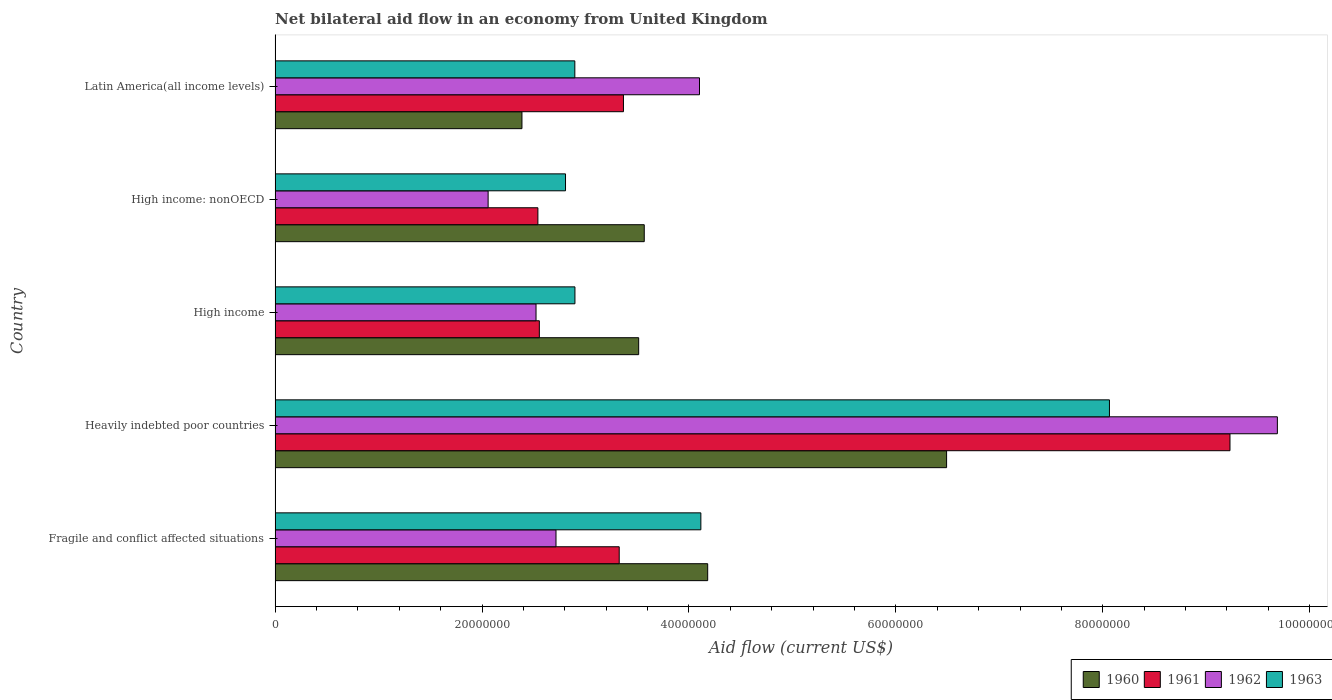How many different coloured bars are there?
Make the answer very short. 4. Are the number of bars on each tick of the Y-axis equal?
Your response must be concise. Yes. How many bars are there on the 1st tick from the top?
Ensure brevity in your answer.  4. What is the label of the 1st group of bars from the top?
Provide a short and direct response. Latin America(all income levels). In how many cases, is the number of bars for a given country not equal to the number of legend labels?
Give a very brief answer. 0. What is the net bilateral aid flow in 1960 in Fragile and conflict affected situations?
Ensure brevity in your answer.  4.18e+07. Across all countries, what is the maximum net bilateral aid flow in 1960?
Provide a succinct answer. 6.49e+07. Across all countries, what is the minimum net bilateral aid flow in 1961?
Ensure brevity in your answer.  2.54e+07. In which country was the net bilateral aid flow in 1962 maximum?
Your answer should be compact. Heavily indebted poor countries. In which country was the net bilateral aid flow in 1960 minimum?
Your answer should be compact. Latin America(all income levels). What is the total net bilateral aid flow in 1963 in the graph?
Your answer should be very brief. 2.08e+08. What is the difference between the net bilateral aid flow in 1961 in Heavily indebted poor countries and that in Latin America(all income levels)?
Offer a terse response. 5.86e+07. What is the difference between the net bilateral aid flow in 1961 in Latin America(all income levels) and the net bilateral aid flow in 1960 in Heavily indebted poor countries?
Keep it short and to the point. -3.12e+07. What is the average net bilateral aid flow in 1960 per country?
Ensure brevity in your answer.  4.03e+07. What is the difference between the net bilateral aid flow in 1963 and net bilateral aid flow in 1960 in Fragile and conflict affected situations?
Your response must be concise. -6.60e+05. In how many countries, is the net bilateral aid flow in 1960 greater than 68000000 US$?
Your answer should be compact. 0. What is the ratio of the net bilateral aid flow in 1960 in High income to that in Latin America(all income levels)?
Make the answer very short. 1.47. Is the net bilateral aid flow in 1963 in Fragile and conflict affected situations less than that in Heavily indebted poor countries?
Provide a succinct answer. Yes. Is the difference between the net bilateral aid flow in 1963 in High income and Latin America(all income levels) greater than the difference between the net bilateral aid flow in 1960 in High income and Latin America(all income levels)?
Provide a short and direct response. No. What is the difference between the highest and the second highest net bilateral aid flow in 1961?
Your answer should be very brief. 5.86e+07. What is the difference between the highest and the lowest net bilateral aid flow in 1961?
Provide a short and direct response. 6.69e+07. In how many countries, is the net bilateral aid flow in 1961 greater than the average net bilateral aid flow in 1961 taken over all countries?
Provide a succinct answer. 1. What is the difference between two consecutive major ticks on the X-axis?
Your response must be concise. 2.00e+07. Does the graph contain grids?
Your response must be concise. No. How are the legend labels stacked?
Your response must be concise. Horizontal. What is the title of the graph?
Offer a terse response. Net bilateral aid flow in an economy from United Kingdom. Does "1972" appear as one of the legend labels in the graph?
Give a very brief answer. No. What is the label or title of the X-axis?
Give a very brief answer. Aid flow (current US$). What is the Aid flow (current US$) of 1960 in Fragile and conflict affected situations?
Offer a very short reply. 4.18e+07. What is the Aid flow (current US$) in 1961 in Fragile and conflict affected situations?
Keep it short and to the point. 3.33e+07. What is the Aid flow (current US$) in 1962 in Fragile and conflict affected situations?
Offer a terse response. 2.72e+07. What is the Aid flow (current US$) in 1963 in Fragile and conflict affected situations?
Your response must be concise. 4.12e+07. What is the Aid flow (current US$) in 1960 in Heavily indebted poor countries?
Keep it short and to the point. 6.49e+07. What is the Aid flow (current US$) of 1961 in Heavily indebted poor countries?
Give a very brief answer. 9.23e+07. What is the Aid flow (current US$) in 1962 in Heavily indebted poor countries?
Keep it short and to the point. 9.69e+07. What is the Aid flow (current US$) of 1963 in Heavily indebted poor countries?
Keep it short and to the point. 8.06e+07. What is the Aid flow (current US$) of 1960 in High income?
Give a very brief answer. 3.51e+07. What is the Aid flow (current US$) in 1961 in High income?
Ensure brevity in your answer.  2.55e+07. What is the Aid flow (current US$) in 1962 in High income?
Keep it short and to the point. 2.52e+07. What is the Aid flow (current US$) in 1963 in High income?
Give a very brief answer. 2.90e+07. What is the Aid flow (current US$) of 1960 in High income: nonOECD?
Keep it short and to the point. 3.57e+07. What is the Aid flow (current US$) of 1961 in High income: nonOECD?
Provide a succinct answer. 2.54e+07. What is the Aid flow (current US$) in 1962 in High income: nonOECD?
Your answer should be very brief. 2.06e+07. What is the Aid flow (current US$) of 1963 in High income: nonOECD?
Your answer should be very brief. 2.81e+07. What is the Aid flow (current US$) in 1960 in Latin America(all income levels)?
Your answer should be very brief. 2.39e+07. What is the Aid flow (current US$) of 1961 in Latin America(all income levels)?
Provide a succinct answer. 3.37e+07. What is the Aid flow (current US$) in 1962 in Latin America(all income levels)?
Your response must be concise. 4.10e+07. What is the Aid flow (current US$) of 1963 in Latin America(all income levels)?
Provide a succinct answer. 2.90e+07. Across all countries, what is the maximum Aid flow (current US$) of 1960?
Provide a short and direct response. 6.49e+07. Across all countries, what is the maximum Aid flow (current US$) in 1961?
Your response must be concise. 9.23e+07. Across all countries, what is the maximum Aid flow (current US$) in 1962?
Provide a succinct answer. 9.69e+07. Across all countries, what is the maximum Aid flow (current US$) of 1963?
Offer a terse response. 8.06e+07. Across all countries, what is the minimum Aid flow (current US$) of 1960?
Ensure brevity in your answer.  2.39e+07. Across all countries, what is the minimum Aid flow (current US$) of 1961?
Your response must be concise. 2.54e+07. Across all countries, what is the minimum Aid flow (current US$) in 1962?
Offer a very short reply. 2.06e+07. Across all countries, what is the minimum Aid flow (current US$) in 1963?
Give a very brief answer. 2.81e+07. What is the total Aid flow (current US$) of 1960 in the graph?
Give a very brief answer. 2.01e+08. What is the total Aid flow (current US$) of 1961 in the graph?
Your answer should be very brief. 2.10e+08. What is the total Aid flow (current US$) of 1962 in the graph?
Provide a succinct answer. 2.11e+08. What is the total Aid flow (current US$) of 1963 in the graph?
Your response must be concise. 2.08e+08. What is the difference between the Aid flow (current US$) in 1960 in Fragile and conflict affected situations and that in Heavily indebted poor countries?
Provide a succinct answer. -2.31e+07. What is the difference between the Aid flow (current US$) in 1961 in Fragile and conflict affected situations and that in Heavily indebted poor countries?
Offer a terse response. -5.90e+07. What is the difference between the Aid flow (current US$) in 1962 in Fragile and conflict affected situations and that in Heavily indebted poor countries?
Your response must be concise. -6.97e+07. What is the difference between the Aid flow (current US$) of 1963 in Fragile and conflict affected situations and that in Heavily indebted poor countries?
Keep it short and to the point. -3.95e+07. What is the difference between the Aid flow (current US$) in 1960 in Fragile and conflict affected situations and that in High income?
Offer a very short reply. 6.67e+06. What is the difference between the Aid flow (current US$) in 1961 in Fragile and conflict affected situations and that in High income?
Provide a short and direct response. 7.72e+06. What is the difference between the Aid flow (current US$) in 1962 in Fragile and conflict affected situations and that in High income?
Give a very brief answer. 1.93e+06. What is the difference between the Aid flow (current US$) in 1963 in Fragile and conflict affected situations and that in High income?
Provide a succinct answer. 1.22e+07. What is the difference between the Aid flow (current US$) of 1960 in Fragile and conflict affected situations and that in High income: nonOECD?
Your answer should be very brief. 6.13e+06. What is the difference between the Aid flow (current US$) in 1961 in Fragile and conflict affected situations and that in High income: nonOECD?
Offer a very short reply. 7.86e+06. What is the difference between the Aid flow (current US$) of 1962 in Fragile and conflict affected situations and that in High income: nonOECD?
Give a very brief answer. 6.56e+06. What is the difference between the Aid flow (current US$) of 1963 in Fragile and conflict affected situations and that in High income: nonOECD?
Give a very brief answer. 1.31e+07. What is the difference between the Aid flow (current US$) of 1960 in Fragile and conflict affected situations and that in Latin America(all income levels)?
Keep it short and to the point. 1.80e+07. What is the difference between the Aid flow (current US$) in 1961 in Fragile and conflict affected situations and that in Latin America(all income levels)?
Your response must be concise. -4.10e+05. What is the difference between the Aid flow (current US$) of 1962 in Fragile and conflict affected situations and that in Latin America(all income levels)?
Keep it short and to the point. -1.39e+07. What is the difference between the Aid flow (current US$) in 1963 in Fragile and conflict affected situations and that in Latin America(all income levels)?
Offer a very short reply. 1.22e+07. What is the difference between the Aid flow (current US$) of 1960 in Heavily indebted poor countries and that in High income?
Give a very brief answer. 2.98e+07. What is the difference between the Aid flow (current US$) in 1961 in Heavily indebted poor countries and that in High income?
Provide a succinct answer. 6.68e+07. What is the difference between the Aid flow (current US$) of 1962 in Heavily indebted poor countries and that in High income?
Offer a terse response. 7.16e+07. What is the difference between the Aid flow (current US$) in 1963 in Heavily indebted poor countries and that in High income?
Give a very brief answer. 5.17e+07. What is the difference between the Aid flow (current US$) in 1960 in Heavily indebted poor countries and that in High income: nonOECD?
Offer a very short reply. 2.92e+07. What is the difference between the Aid flow (current US$) in 1961 in Heavily indebted poor countries and that in High income: nonOECD?
Your response must be concise. 6.69e+07. What is the difference between the Aid flow (current US$) in 1962 in Heavily indebted poor countries and that in High income: nonOECD?
Provide a short and direct response. 7.63e+07. What is the difference between the Aid flow (current US$) in 1963 in Heavily indebted poor countries and that in High income: nonOECD?
Your answer should be compact. 5.26e+07. What is the difference between the Aid flow (current US$) of 1960 in Heavily indebted poor countries and that in Latin America(all income levels)?
Ensure brevity in your answer.  4.10e+07. What is the difference between the Aid flow (current US$) of 1961 in Heavily indebted poor countries and that in Latin America(all income levels)?
Ensure brevity in your answer.  5.86e+07. What is the difference between the Aid flow (current US$) in 1962 in Heavily indebted poor countries and that in Latin America(all income levels)?
Offer a terse response. 5.58e+07. What is the difference between the Aid flow (current US$) of 1963 in Heavily indebted poor countries and that in Latin America(all income levels)?
Ensure brevity in your answer.  5.17e+07. What is the difference between the Aid flow (current US$) of 1960 in High income and that in High income: nonOECD?
Provide a succinct answer. -5.40e+05. What is the difference between the Aid flow (current US$) in 1962 in High income and that in High income: nonOECD?
Make the answer very short. 4.63e+06. What is the difference between the Aid flow (current US$) in 1963 in High income and that in High income: nonOECD?
Keep it short and to the point. 9.10e+05. What is the difference between the Aid flow (current US$) of 1960 in High income and that in Latin America(all income levels)?
Your answer should be very brief. 1.13e+07. What is the difference between the Aid flow (current US$) of 1961 in High income and that in Latin America(all income levels)?
Make the answer very short. -8.13e+06. What is the difference between the Aid flow (current US$) of 1962 in High income and that in Latin America(all income levels)?
Keep it short and to the point. -1.58e+07. What is the difference between the Aid flow (current US$) in 1963 in High income and that in Latin America(all income levels)?
Provide a short and direct response. 10000. What is the difference between the Aid flow (current US$) in 1960 in High income: nonOECD and that in Latin America(all income levels)?
Provide a short and direct response. 1.18e+07. What is the difference between the Aid flow (current US$) in 1961 in High income: nonOECD and that in Latin America(all income levels)?
Your answer should be very brief. -8.27e+06. What is the difference between the Aid flow (current US$) in 1962 in High income: nonOECD and that in Latin America(all income levels)?
Give a very brief answer. -2.04e+07. What is the difference between the Aid flow (current US$) in 1963 in High income: nonOECD and that in Latin America(all income levels)?
Provide a succinct answer. -9.00e+05. What is the difference between the Aid flow (current US$) in 1960 in Fragile and conflict affected situations and the Aid flow (current US$) in 1961 in Heavily indebted poor countries?
Offer a terse response. -5.05e+07. What is the difference between the Aid flow (current US$) in 1960 in Fragile and conflict affected situations and the Aid flow (current US$) in 1962 in Heavily indebted poor countries?
Offer a very short reply. -5.51e+07. What is the difference between the Aid flow (current US$) in 1960 in Fragile and conflict affected situations and the Aid flow (current US$) in 1963 in Heavily indebted poor countries?
Provide a short and direct response. -3.88e+07. What is the difference between the Aid flow (current US$) of 1961 in Fragile and conflict affected situations and the Aid flow (current US$) of 1962 in Heavily indebted poor countries?
Provide a succinct answer. -6.36e+07. What is the difference between the Aid flow (current US$) of 1961 in Fragile and conflict affected situations and the Aid flow (current US$) of 1963 in Heavily indebted poor countries?
Your answer should be compact. -4.74e+07. What is the difference between the Aid flow (current US$) of 1962 in Fragile and conflict affected situations and the Aid flow (current US$) of 1963 in Heavily indebted poor countries?
Your response must be concise. -5.35e+07. What is the difference between the Aid flow (current US$) of 1960 in Fragile and conflict affected situations and the Aid flow (current US$) of 1961 in High income?
Offer a very short reply. 1.63e+07. What is the difference between the Aid flow (current US$) in 1960 in Fragile and conflict affected situations and the Aid flow (current US$) in 1962 in High income?
Ensure brevity in your answer.  1.66e+07. What is the difference between the Aid flow (current US$) in 1960 in Fragile and conflict affected situations and the Aid flow (current US$) in 1963 in High income?
Offer a very short reply. 1.28e+07. What is the difference between the Aid flow (current US$) of 1961 in Fragile and conflict affected situations and the Aid flow (current US$) of 1962 in High income?
Provide a succinct answer. 8.04e+06. What is the difference between the Aid flow (current US$) in 1961 in Fragile and conflict affected situations and the Aid flow (current US$) in 1963 in High income?
Give a very brief answer. 4.28e+06. What is the difference between the Aid flow (current US$) of 1962 in Fragile and conflict affected situations and the Aid flow (current US$) of 1963 in High income?
Offer a terse response. -1.83e+06. What is the difference between the Aid flow (current US$) in 1960 in Fragile and conflict affected situations and the Aid flow (current US$) in 1961 in High income: nonOECD?
Offer a terse response. 1.64e+07. What is the difference between the Aid flow (current US$) of 1960 in Fragile and conflict affected situations and the Aid flow (current US$) of 1962 in High income: nonOECD?
Provide a short and direct response. 2.12e+07. What is the difference between the Aid flow (current US$) in 1960 in Fragile and conflict affected situations and the Aid flow (current US$) in 1963 in High income: nonOECD?
Offer a very short reply. 1.37e+07. What is the difference between the Aid flow (current US$) in 1961 in Fragile and conflict affected situations and the Aid flow (current US$) in 1962 in High income: nonOECD?
Ensure brevity in your answer.  1.27e+07. What is the difference between the Aid flow (current US$) in 1961 in Fragile and conflict affected situations and the Aid flow (current US$) in 1963 in High income: nonOECD?
Offer a terse response. 5.19e+06. What is the difference between the Aid flow (current US$) of 1962 in Fragile and conflict affected situations and the Aid flow (current US$) of 1963 in High income: nonOECD?
Make the answer very short. -9.20e+05. What is the difference between the Aid flow (current US$) in 1960 in Fragile and conflict affected situations and the Aid flow (current US$) in 1961 in Latin America(all income levels)?
Offer a terse response. 8.14e+06. What is the difference between the Aid flow (current US$) of 1960 in Fragile and conflict affected situations and the Aid flow (current US$) of 1962 in Latin America(all income levels)?
Ensure brevity in your answer.  7.90e+05. What is the difference between the Aid flow (current US$) in 1960 in Fragile and conflict affected situations and the Aid flow (current US$) in 1963 in Latin America(all income levels)?
Offer a terse response. 1.28e+07. What is the difference between the Aid flow (current US$) in 1961 in Fragile and conflict affected situations and the Aid flow (current US$) in 1962 in Latin America(all income levels)?
Provide a succinct answer. -7.76e+06. What is the difference between the Aid flow (current US$) in 1961 in Fragile and conflict affected situations and the Aid flow (current US$) in 1963 in Latin America(all income levels)?
Make the answer very short. 4.29e+06. What is the difference between the Aid flow (current US$) of 1962 in Fragile and conflict affected situations and the Aid flow (current US$) of 1963 in Latin America(all income levels)?
Ensure brevity in your answer.  -1.82e+06. What is the difference between the Aid flow (current US$) of 1960 in Heavily indebted poor countries and the Aid flow (current US$) of 1961 in High income?
Your answer should be compact. 3.94e+07. What is the difference between the Aid flow (current US$) of 1960 in Heavily indebted poor countries and the Aid flow (current US$) of 1962 in High income?
Keep it short and to the point. 3.97e+07. What is the difference between the Aid flow (current US$) of 1960 in Heavily indebted poor countries and the Aid flow (current US$) of 1963 in High income?
Make the answer very short. 3.59e+07. What is the difference between the Aid flow (current US$) in 1961 in Heavily indebted poor countries and the Aid flow (current US$) in 1962 in High income?
Provide a succinct answer. 6.71e+07. What is the difference between the Aid flow (current US$) in 1961 in Heavily indebted poor countries and the Aid flow (current US$) in 1963 in High income?
Offer a very short reply. 6.33e+07. What is the difference between the Aid flow (current US$) in 1962 in Heavily indebted poor countries and the Aid flow (current US$) in 1963 in High income?
Your answer should be very brief. 6.79e+07. What is the difference between the Aid flow (current US$) in 1960 in Heavily indebted poor countries and the Aid flow (current US$) in 1961 in High income: nonOECD?
Make the answer very short. 3.95e+07. What is the difference between the Aid flow (current US$) of 1960 in Heavily indebted poor countries and the Aid flow (current US$) of 1962 in High income: nonOECD?
Give a very brief answer. 4.43e+07. What is the difference between the Aid flow (current US$) in 1960 in Heavily indebted poor countries and the Aid flow (current US$) in 1963 in High income: nonOECD?
Offer a very short reply. 3.68e+07. What is the difference between the Aid flow (current US$) of 1961 in Heavily indebted poor countries and the Aid flow (current US$) of 1962 in High income: nonOECD?
Your response must be concise. 7.17e+07. What is the difference between the Aid flow (current US$) in 1961 in Heavily indebted poor countries and the Aid flow (current US$) in 1963 in High income: nonOECD?
Make the answer very short. 6.42e+07. What is the difference between the Aid flow (current US$) in 1962 in Heavily indebted poor countries and the Aid flow (current US$) in 1963 in High income: nonOECD?
Offer a terse response. 6.88e+07. What is the difference between the Aid flow (current US$) in 1960 in Heavily indebted poor countries and the Aid flow (current US$) in 1961 in Latin America(all income levels)?
Ensure brevity in your answer.  3.12e+07. What is the difference between the Aid flow (current US$) of 1960 in Heavily indebted poor countries and the Aid flow (current US$) of 1962 in Latin America(all income levels)?
Make the answer very short. 2.39e+07. What is the difference between the Aid flow (current US$) of 1960 in Heavily indebted poor countries and the Aid flow (current US$) of 1963 in Latin America(all income levels)?
Keep it short and to the point. 3.59e+07. What is the difference between the Aid flow (current US$) of 1961 in Heavily indebted poor countries and the Aid flow (current US$) of 1962 in Latin America(all income levels)?
Provide a succinct answer. 5.13e+07. What is the difference between the Aid flow (current US$) in 1961 in Heavily indebted poor countries and the Aid flow (current US$) in 1963 in Latin America(all income levels)?
Offer a very short reply. 6.33e+07. What is the difference between the Aid flow (current US$) of 1962 in Heavily indebted poor countries and the Aid flow (current US$) of 1963 in Latin America(all income levels)?
Offer a terse response. 6.79e+07. What is the difference between the Aid flow (current US$) of 1960 in High income and the Aid flow (current US$) of 1961 in High income: nonOECD?
Offer a terse response. 9.74e+06. What is the difference between the Aid flow (current US$) of 1960 in High income and the Aid flow (current US$) of 1962 in High income: nonOECD?
Provide a short and direct response. 1.46e+07. What is the difference between the Aid flow (current US$) in 1960 in High income and the Aid flow (current US$) in 1963 in High income: nonOECD?
Make the answer very short. 7.07e+06. What is the difference between the Aid flow (current US$) in 1961 in High income and the Aid flow (current US$) in 1962 in High income: nonOECD?
Give a very brief answer. 4.95e+06. What is the difference between the Aid flow (current US$) of 1961 in High income and the Aid flow (current US$) of 1963 in High income: nonOECD?
Provide a short and direct response. -2.53e+06. What is the difference between the Aid flow (current US$) of 1962 in High income and the Aid flow (current US$) of 1963 in High income: nonOECD?
Keep it short and to the point. -2.85e+06. What is the difference between the Aid flow (current US$) of 1960 in High income and the Aid flow (current US$) of 1961 in Latin America(all income levels)?
Ensure brevity in your answer.  1.47e+06. What is the difference between the Aid flow (current US$) in 1960 in High income and the Aid flow (current US$) in 1962 in Latin America(all income levels)?
Give a very brief answer. -5.88e+06. What is the difference between the Aid flow (current US$) of 1960 in High income and the Aid flow (current US$) of 1963 in Latin America(all income levels)?
Give a very brief answer. 6.17e+06. What is the difference between the Aid flow (current US$) in 1961 in High income and the Aid flow (current US$) in 1962 in Latin America(all income levels)?
Keep it short and to the point. -1.55e+07. What is the difference between the Aid flow (current US$) of 1961 in High income and the Aid flow (current US$) of 1963 in Latin America(all income levels)?
Keep it short and to the point. -3.43e+06. What is the difference between the Aid flow (current US$) in 1962 in High income and the Aid flow (current US$) in 1963 in Latin America(all income levels)?
Give a very brief answer. -3.75e+06. What is the difference between the Aid flow (current US$) in 1960 in High income: nonOECD and the Aid flow (current US$) in 1961 in Latin America(all income levels)?
Your response must be concise. 2.01e+06. What is the difference between the Aid flow (current US$) in 1960 in High income: nonOECD and the Aid flow (current US$) in 1962 in Latin America(all income levels)?
Ensure brevity in your answer.  -5.34e+06. What is the difference between the Aid flow (current US$) in 1960 in High income: nonOECD and the Aid flow (current US$) in 1963 in Latin America(all income levels)?
Your response must be concise. 6.71e+06. What is the difference between the Aid flow (current US$) of 1961 in High income: nonOECD and the Aid flow (current US$) of 1962 in Latin America(all income levels)?
Provide a short and direct response. -1.56e+07. What is the difference between the Aid flow (current US$) in 1961 in High income: nonOECD and the Aid flow (current US$) in 1963 in Latin America(all income levels)?
Your answer should be compact. -3.57e+06. What is the difference between the Aid flow (current US$) in 1962 in High income: nonOECD and the Aid flow (current US$) in 1963 in Latin America(all income levels)?
Your answer should be compact. -8.38e+06. What is the average Aid flow (current US$) in 1960 per country?
Your response must be concise. 4.03e+07. What is the average Aid flow (current US$) in 1961 per country?
Provide a succinct answer. 4.20e+07. What is the average Aid flow (current US$) of 1962 per country?
Your answer should be very brief. 4.22e+07. What is the average Aid flow (current US$) in 1963 per country?
Your response must be concise. 4.16e+07. What is the difference between the Aid flow (current US$) of 1960 and Aid flow (current US$) of 1961 in Fragile and conflict affected situations?
Provide a short and direct response. 8.55e+06. What is the difference between the Aid flow (current US$) in 1960 and Aid flow (current US$) in 1962 in Fragile and conflict affected situations?
Offer a terse response. 1.47e+07. What is the difference between the Aid flow (current US$) in 1960 and Aid flow (current US$) in 1963 in Fragile and conflict affected situations?
Your answer should be very brief. 6.60e+05. What is the difference between the Aid flow (current US$) in 1961 and Aid flow (current US$) in 1962 in Fragile and conflict affected situations?
Offer a very short reply. 6.11e+06. What is the difference between the Aid flow (current US$) of 1961 and Aid flow (current US$) of 1963 in Fragile and conflict affected situations?
Offer a very short reply. -7.89e+06. What is the difference between the Aid flow (current US$) of 1962 and Aid flow (current US$) of 1963 in Fragile and conflict affected situations?
Give a very brief answer. -1.40e+07. What is the difference between the Aid flow (current US$) in 1960 and Aid flow (current US$) in 1961 in Heavily indebted poor countries?
Offer a terse response. -2.74e+07. What is the difference between the Aid flow (current US$) of 1960 and Aid flow (current US$) of 1962 in Heavily indebted poor countries?
Offer a terse response. -3.20e+07. What is the difference between the Aid flow (current US$) in 1960 and Aid flow (current US$) in 1963 in Heavily indebted poor countries?
Your answer should be compact. -1.57e+07. What is the difference between the Aid flow (current US$) of 1961 and Aid flow (current US$) of 1962 in Heavily indebted poor countries?
Ensure brevity in your answer.  -4.58e+06. What is the difference between the Aid flow (current US$) in 1961 and Aid flow (current US$) in 1963 in Heavily indebted poor countries?
Provide a succinct answer. 1.16e+07. What is the difference between the Aid flow (current US$) in 1962 and Aid flow (current US$) in 1963 in Heavily indebted poor countries?
Provide a succinct answer. 1.62e+07. What is the difference between the Aid flow (current US$) of 1960 and Aid flow (current US$) of 1961 in High income?
Provide a succinct answer. 9.60e+06. What is the difference between the Aid flow (current US$) in 1960 and Aid flow (current US$) in 1962 in High income?
Give a very brief answer. 9.92e+06. What is the difference between the Aid flow (current US$) in 1960 and Aid flow (current US$) in 1963 in High income?
Keep it short and to the point. 6.16e+06. What is the difference between the Aid flow (current US$) in 1961 and Aid flow (current US$) in 1962 in High income?
Provide a succinct answer. 3.20e+05. What is the difference between the Aid flow (current US$) of 1961 and Aid flow (current US$) of 1963 in High income?
Ensure brevity in your answer.  -3.44e+06. What is the difference between the Aid flow (current US$) of 1962 and Aid flow (current US$) of 1963 in High income?
Ensure brevity in your answer.  -3.76e+06. What is the difference between the Aid flow (current US$) of 1960 and Aid flow (current US$) of 1961 in High income: nonOECD?
Provide a succinct answer. 1.03e+07. What is the difference between the Aid flow (current US$) of 1960 and Aid flow (current US$) of 1962 in High income: nonOECD?
Offer a terse response. 1.51e+07. What is the difference between the Aid flow (current US$) in 1960 and Aid flow (current US$) in 1963 in High income: nonOECD?
Offer a terse response. 7.61e+06. What is the difference between the Aid flow (current US$) of 1961 and Aid flow (current US$) of 1962 in High income: nonOECD?
Your response must be concise. 4.81e+06. What is the difference between the Aid flow (current US$) in 1961 and Aid flow (current US$) in 1963 in High income: nonOECD?
Offer a terse response. -2.67e+06. What is the difference between the Aid flow (current US$) in 1962 and Aid flow (current US$) in 1963 in High income: nonOECD?
Give a very brief answer. -7.48e+06. What is the difference between the Aid flow (current US$) of 1960 and Aid flow (current US$) of 1961 in Latin America(all income levels)?
Provide a short and direct response. -9.81e+06. What is the difference between the Aid flow (current US$) of 1960 and Aid flow (current US$) of 1962 in Latin America(all income levels)?
Keep it short and to the point. -1.72e+07. What is the difference between the Aid flow (current US$) of 1960 and Aid flow (current US$) of 1963 in Latin America(all income levels)?
Provide a succinct answer. -5.11e+06. What is the difference between the Aid flow (current US$) of 1961 and Aid flow (current US$) of 1962 in Latin America(all income levels)?
Keep it short and to the point. -7.35e+06. What is the difference between the Aid flow (current US$) of 1961 and Aid flow (current US$) of 1963 in Latin America(all income levels)?
Provide a succinct answer. 4.70e+06. What is the difference between the Aid flow (current US$) of 1962 and Aid flow (current US$) of 1963 in Latin America(all income levels)?
Make the answer very short. 1.20e+07. What is the ratio of the Aid flow (current US$) of 1960 in Fragile and conflict affected situations to that in Heavily indebted poor countries?
Your answer should be compact. 0.64. What is the ratio of the Aid flow (current US$) of 1961 in Fragile and conflict affected situations to that in Heavily indebted poor countries?
Your response must be concise. 0.36. What is the ratio of the Aid flow (current US$) of 1962 in Fragile and conflict affected situations to that in Heavily indebted poor countries?
Your answer should be very brief. 0.28. What is the ratio of the Aid flow (current US$) of 1963 in Fragile and conflict affected situations to that in Heavily indebted poor countries?
Keep it short and to the point. 0.51. What is the ratio of the Aid flow (current US$) of 1960 in Fragile and conflict affected situations to that in High income?
Offer a terse response. 1.19. What is the ratio of the Aid flow (current US$) in 1961 in Fragile and conflict affected situations to that in High income?
Provide a short and direct response. 1.3. What is the ratio of the Aid flow (current US$) of 1962 in Fragile and conflict affected situations to that in High income?
Your answer should be very brief. 1.08. What is the ratio of the Aid flow (current US$) of 1963 in Fragile and conflict affected situations to that in High income?
Keep it short and to the point. 1.42. What is the ratio of the Aid flow (current US$) of 1960 in Fragile and conflict affected situations to that in High income: nonOECD?
Your answer should be compact. 1.17. What is the ratio of the Aid flow (current US$) of 1961 in Fragile and conflict affected situations to that in High income: nonOECD?
Offer a very short reply. 1.31. What is the ratio of the Aid flow (current US$) of 1962 in Fragile and conflict affected situations to that in High income: nonOECD?
Ensure brevity in your answer.  1.32. What is the ratio of the Aid flow (current US$) in 1963 in Fragile and conflict affected situations to that in High income: nonOECD?
Give a very brief answer. 1.47. What is the ratio of the Aid flow (current US$) in 1960 in Fragile and conflict affected situations to that in Latin America(all income levels)?
Your response must be concise. 1.75. What is the ratio of the Aid flow (current US$) in 1961 in Fragile and conflict affected situations to that in Latin America(all income levels)?
Ensure brevity in your answer.  0.99. What is the ratio of the Aid flow (current US$) of 1962 in Fragile and conflict affected situations to that in Latin America(all income levels)?
Your answer should be compact. 0.66. What is the ratio of the Aid flow (current US$) of 1963 in Fragile and conflict affected situations to that in Latin America(all income levels)?
Provide a succinct answer. 1.42. What is the ratio of the Aid flow (current US$) of 1960 in Heavily indebted poor countries to that in High income?
Ensure brevity in your answer.  1.85. What is the ratio of the Aid flow (current US$) of 1961 in Heavily indebted poor countries to that in High income?
Ensure brevity in your answer.  3.61. What is the ratio of the Aid flow (current US$) of 1962 in Heavily indebted poor countries to that in High income?
Ensure brevity in your answer.  3.84. What is the ratio of the Aid flow (current US$) of 1963 in Heavily indebted poor countries to that in High income?
Provide a short and direct response. 2.78. What is the ratio of the Aid flow (current US$) in 1960 in Heavily indebted poor countries to that in High income: nonOECD?
Ensure brevity in your answer.  1.82. What is the ratio of the Aid flow (current US$) in 1961 in Heavily indebted poor countries to that in High income: nonOECD?
Ensure brevity in your answer.  3.63. What is the ratio of the Aid flow (current US$) in 1962 in Heavily indebted poor countries to that in High income: nonOECD?
Provide a succinct answer. 4.7. What is the ratio of the Aid flow (current US$) in 1963 in Heavily indebted poor countries to that in High income: nonOECD?
Your answer should be compact. 2.87. What is the ratio of the Aid flow (current US$) of 1960 in Heavily indebted poor countries to that in Latin America(all income levels)?
Provide a succinct answer. 2.72. What is the ratio of the Aid flow (current US$) in 1961 in Heavily indebted poor countries to that in Latin America(all income levels)?
Offer a terse response. 2.74. What is the ratio of the Aid flow (current US$) in 1962 in Heavily indebted poor countries to that in Latin America(all income levels)?
Offer a terse response. 2.36. What is the ratio of the Aid flow (current US$) in 1963 in Heavily indebted poor countries to that in Latin America(all income levels)?
Give a very brief answer. 2.78. What is the ratio of the Aid flow (current US$) of 1960 in High income to that in High income: nonOECD?
Your response must be concise. 0.98. What is the ratio of the Aid flow (current US$) in 1962 in High income to that in High income: nonOECD?
Your answer should be compact. 1.22. What is the ratio of the Aid flow (current US$) in 1963 in High income to that in High income: nonOECD?
Provide a succinct answer. 1.03. What is the ratio of the Aid flow (current US$) in 1960 in High income to that in Latin America(all income levels)?
Ensure brevity in your answer.  1.47. What is the ratio of the Aid flow (current US$) of 1961 in High income to that in Latin America(all income levels)?
Give a very brief answer. 0.76. What is the ratio of the Aid flow (current US$) of 1962 in High income to that in Latin America(all income levels)?
Your answer should be very brief. 0.61. What is the ratio of the Aid flow (current US$) of 1960 in High income: nonOECD to that in Latin America(all income levels)?
Offer a terse response. 1.5. What is the ratio of the Aid flow (current US$) of 1961 in High income: nonOECD to that in Latin America(all income levels)?
Your response must be concise. 0.75. What is the ratio of the Aid flow (current US$) of 1962 in High income: nonOECD to that in Latin America(all income levels)?
Your response must be concise. 0.5. What is the ratio of the Aid flow (current US$) of 1963 in High income: nonOECD to that in Latin America(all income levels)?
Offer a terse response. 0.97. What is the difference between the highest and the second highest Aid flow (current US$) in 1960?
Offer a terse response. 2.31e+07. What is the difference between the highest and the second highest Aid flow (current US$) of 1961?
Your response must be concise. 5.86e+07. What is the difference between the highest and the second highest Aid flow (current US$) of 1962?
Provide a succinct answer. 5.58e+07. What is the difference between the highest and the second highest Aid flow (current US$) of 1963?
Provide a short and direct response. 3.95e+07. What is the difference between the highest and the lowest Aid flow (current US$) in 1960?
Your answer should be compact. 4.10e+07. What is the difference between the highest and the lowest Aid flow (current US$) in 1961?
Provide a succinct answer. 6.69e+07. What is the difference between the highest and the lowest Aid flow (current US$) of 1962?
Provide a short and direct response. 7.63e+07. What is the difference between the highest and the lowest Aid flow (current US$) of 1963?
Offer a very short reply. 5.26e+07. 